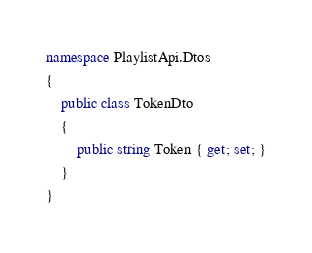<code> <loc_0><loc_0><loc_500><loc_500><_C#_>namespace PlaylistApi.Dtos
{
    public class TokenDto
    {
        public string Token { get; set; }
    }
}
</code> 